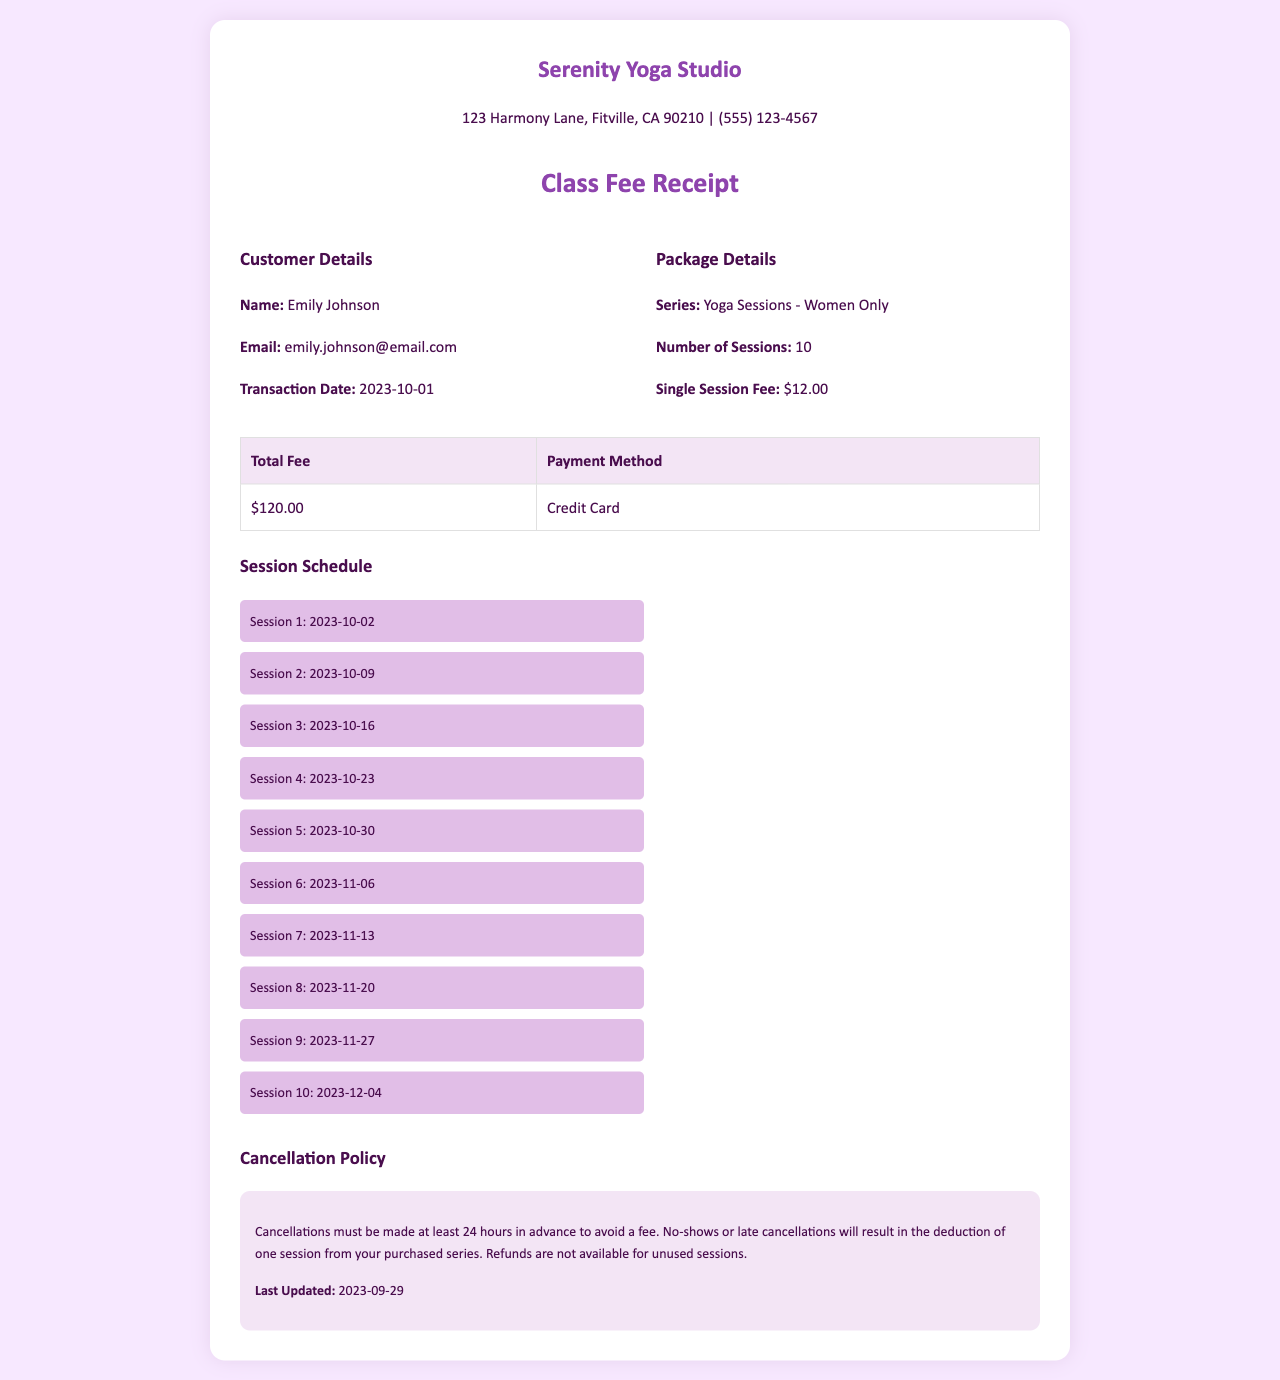what is the name of the studio? The name of the studio is mentioned prominently at the beginning of the document.
Answer: Serenity Yoga Studio what is the email of the customer? The customer's email is provided in the customer details section of the receipt.
Answer: emily.johnson@email.com when was the transaction date? The transaction date is listed within the customer information section.
Answer: 2023-10-01 how many sessions are included in the package? The number of sessions in the package is clearly stated in the package details.
Answer: 10 what is the fee for a single session? The single session fee is noted in the package details section.
Answer: $12.00 what date is the last session scheduled for? The date of the last session is supplied in the session schedule section.
Answer: 2023-12-04 how much is the total fee for the package? The total fee is provided in the table showing payment information.
Answer: $120.00 what is the cancellation policy related to no-shows? The cancellation policy discusses the consequences of no-shows in the cancellation policy section.
Answer: Deduction of one session how many days in advance must cancellations be made? This information is specified in the cancellation policy section.
Answer: 24 hours when was the cancellation policy last updated? The last updated date of the cancellation policy is stated at the end of that section.
Answer: 2023-09-29 